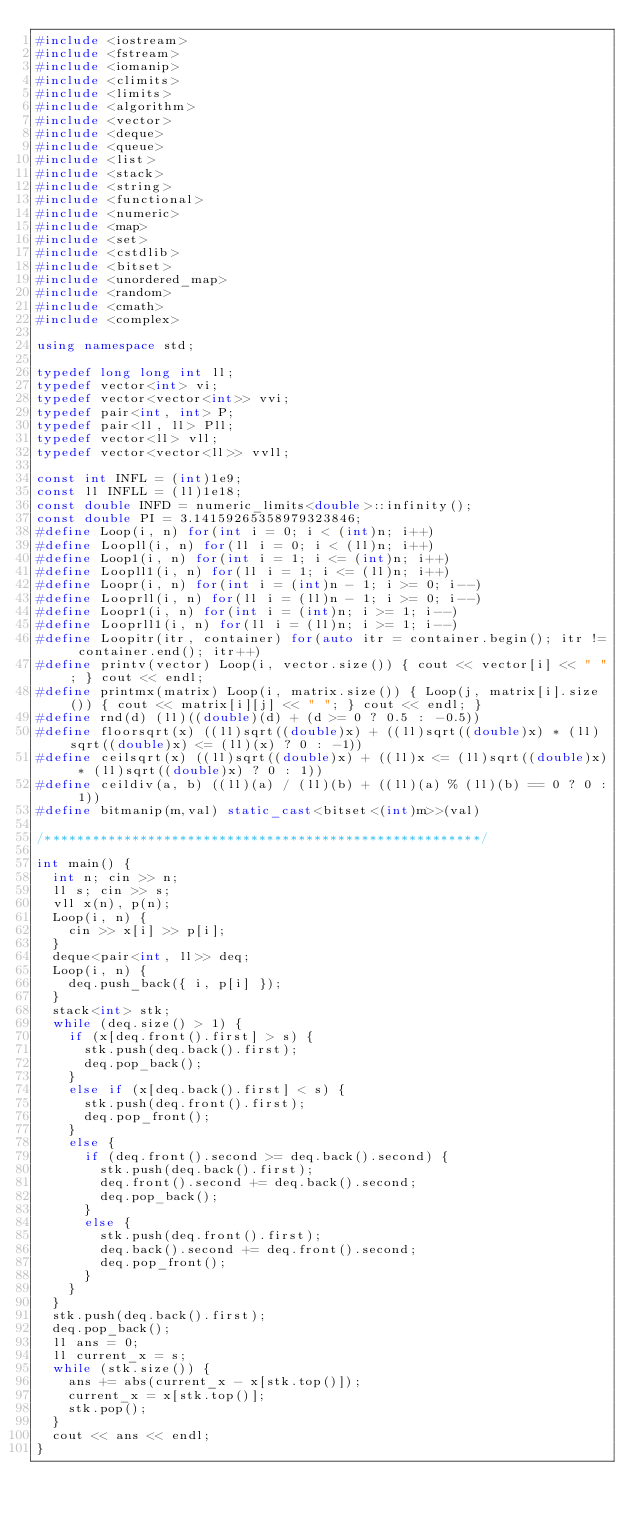<code> <loc_0><loc_0><loc_500><loc_500><_C++_>#include <iostream>
#include <fstream>
#include <iomanip>
#include <climits>
#include <limits>
#include <algorithm>
#include <vector>
#include <deque>
#include <queue>
#include <list>
#include <stack>
#include <string>
#include <functional>
#include <numeric>
#include <map>
#include <set>
#include <cstdlib>
#include <bitset>
#include <unordered_map>
#include <random>
#include <cmath>
#include <complex>

using namespace std;

typedef long long int ll;
typedef vector<int> vi;
typedef vector<vector<int>> vvi;
typedef pair<int, int> P;
typedef pair<ll, ll> Pll;
typedef vector<ll> vll;
typedef vector<vector<ll>> vvll;

const int INFL = (int)1e9;
const ll INFLL = (ll)1e18;
const double INFD = numeric_limits<double>::infinity();
const double PI = 3.14159265358979323846;
#define Loop(i, n) for(int i = 0; i < (int)n; i++)
#define Loopll(i, n) for(ll i = 0; i < (ll)n; i++)
#define Loop1(i, n) for(int i = 1; i <= (int)n; i++)
#define Loopll1(i, n) for(ll i = 1; i <= (ll)n; i++)
#define Loopr(i, n) for(int i = (int)n - 1; i >= 0; i--)
#define Looprll(i, n) for(ll i = (ll)n - 1; i >= 0; i--)
#define Loopr1(i, n) for(int i = (int)n; i >= 1; i--)
#define Looprll1(i, n) for(ll i = (ll)n; i >= 1; i--)
#define Loopitr(itr, container) for(auto itr = container.begin(); itr != container.end(); itr++)
#define printv(vector) Loop(i, vector.size()) { cout << vector[i] << " "; } cout << endl;
#define printmx(matrix) Loop(i, matrix.size()) { Loop(j, matrix[i].size()) { cout << matrix[i][j] << " "; } cout << endl; }
#define rnd(d) (ll)((double)(d) + (d >= 0 ? 0.5 : -0.5))
#define floorsqrt(x) ((ll)sqrt((double)x) + ((ll)sqrt((double)x) * (ll)sqrt((double)x) <= (ll)(x) ? 0 : -1))
#define ceilsqrt(x) ((ll)sqrt((double)x) + ((ll)x <= (ll)sqrt((double)x) * (ll)sqrt((double)x) ? 0 : 1))
#define ceildiv(a, b) ((ll)(a) / (ll)(b) + ((ll)(a) % (ll)(b) == 0 ? 0 : 1))
#define bitmanip(m,val) static_cast<bitset<(int)m>>(val)

/*******************************************************/

int main() {
	int n; cin >> n;
	ll s; cin >> s;
	vll x(n), p(n);
	Loop(i, n) {
		cin >> x[i] >> p[i];
	}
	deque<pair<int, ll>> deq;
	Loop(i, n) {
		deq.push_back({ i, p[i] });
	}
	stack<int> stk;
	while (deq.size() > 1) {
		if (x[deq.front().first] > s) {
			stk.push(deq.back().first);
			deq.pop_back();
		}
		else if (x[deq.back().first] < s) {
			stk.push(deq.front().first);
			deq.pop_front();
		}
		else {
			if (deq.front().second >= deq.back().second) {
				stk.push(deq.back().first);
				deq.front().second += deq.back().second;
				deq.pop_back();
			}
			else {
				stk.push(deq.front().first);
				deq.back().second += deq.front().second;
				deq.pop_front();
			}
		}
	}
	stk.push(deq.back().first);
	deq.pop_back();
	ll ans = 0;
	ll current_x = s;
	while (stk.size()) {
		ans += abs(current_x - x[stk.top()]);
		current_x = x[stk.top()];
		stk.pop();
	}
	cout << ans << endl;
}</code> 